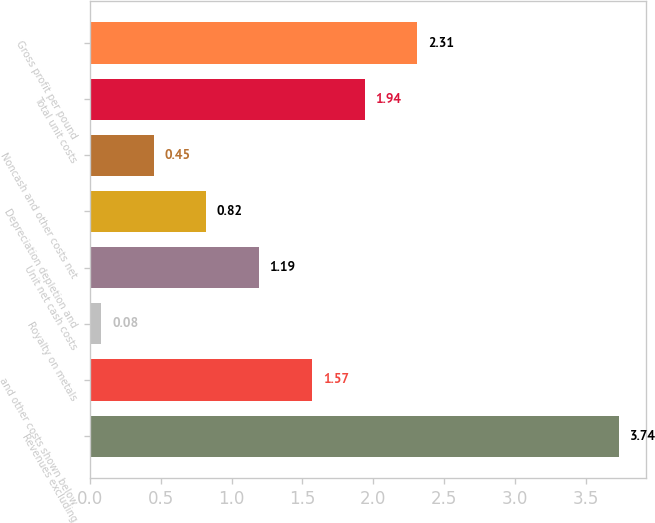Convert chart to OTSL. <chart><loc_0><loc_0><loc_500><loc_500><bar_chart><fcel>Revenues excluding<fcel>and other costs shown below<fcel>Royalty on metals<fcel>Unit net cash costs<fcel>Depreciation depletion and<fcel>Noncash and other costs net<fcel>Total unit costs<fcel>Gross profit per pound<nl><fcel>3.74<fcel>1.57<fcel>0.08<fcel>1.19<fcel>0.82<fcel>0.45<fcel>1.94<fcel>2.31<nl></chart> 